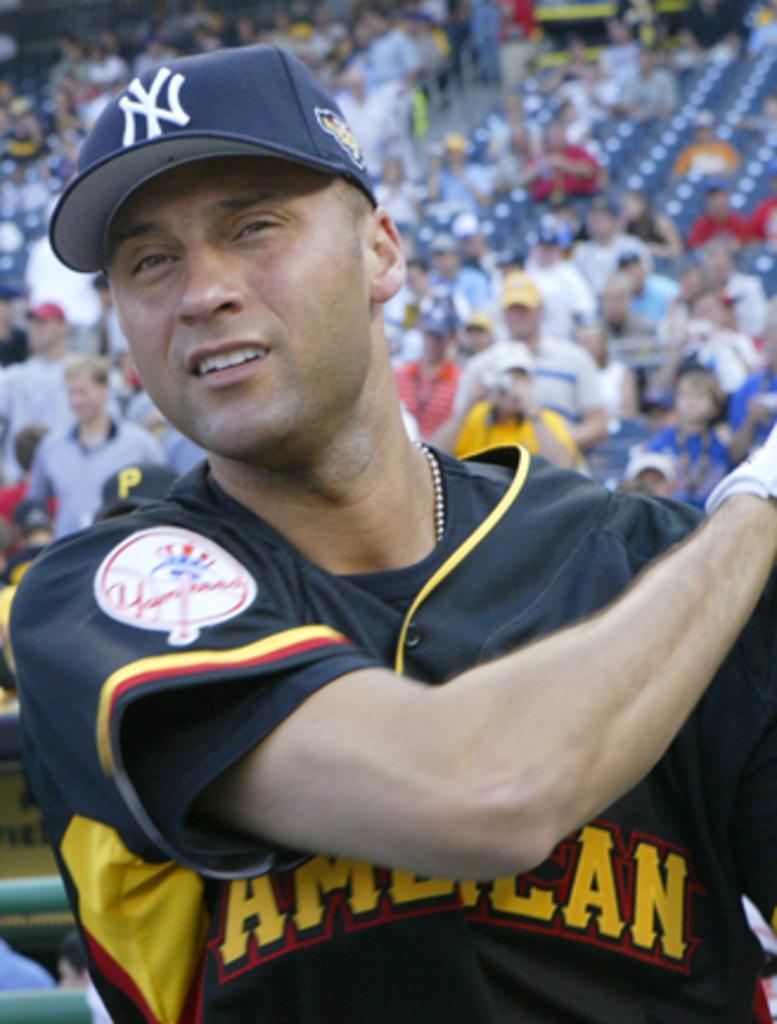What team does he play for?
Your answer should be very brief. Yankees. 